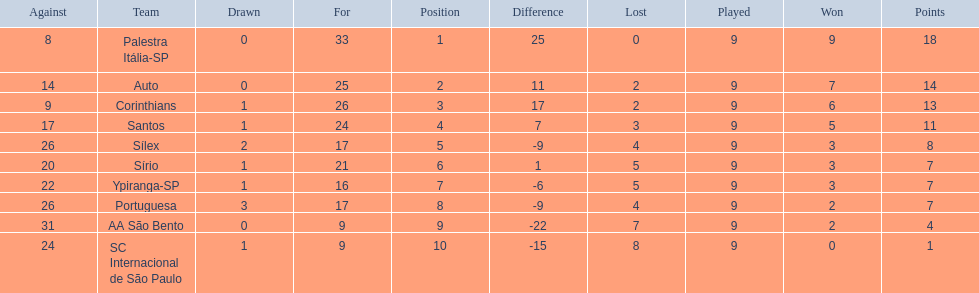What are all the teams? Palestra Itália-SP, Auto, Corinthians, Santos, Sílex, Sírio, Ypiranga-SP, Portuguesa, AA São Bento, SC Internacional de São Paulo. How many times did each team lose? 0, 2, 2, 3, 4, 5, 5, 4, 7, 8. And which team never lost? Palestra Itália-SP. 